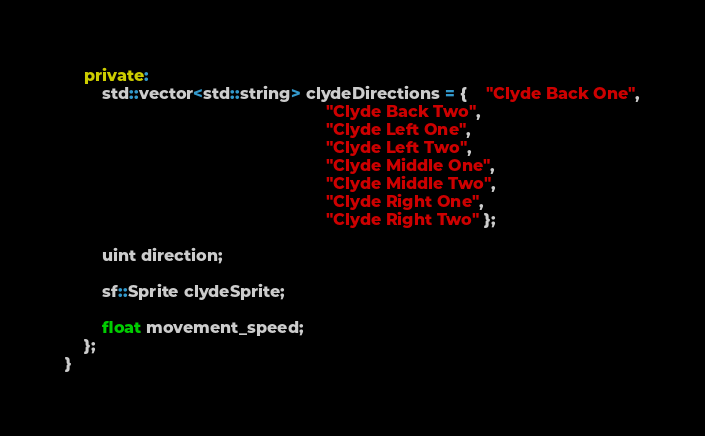Convert code to text. <code><loc_0><loc_0><loc_500><loc_500><_C++_>    private:
        std::vector<std::string> clydeDirections = {    "Clyde Back One",
                                                        "Clyde Back Two",
                                                        "Clyde Left One",
                                                        "Clyde Left Two",
                                                        "Clyde Middle One",
                                                        "Clyde Middle Two",
                                                        "Clyde Right One",
                                                        "Clyde Right Two" };
                                    
        uint direction;

        sf::Sprite clydeSprite;

        float movement_speed;
    };
}
</code> 